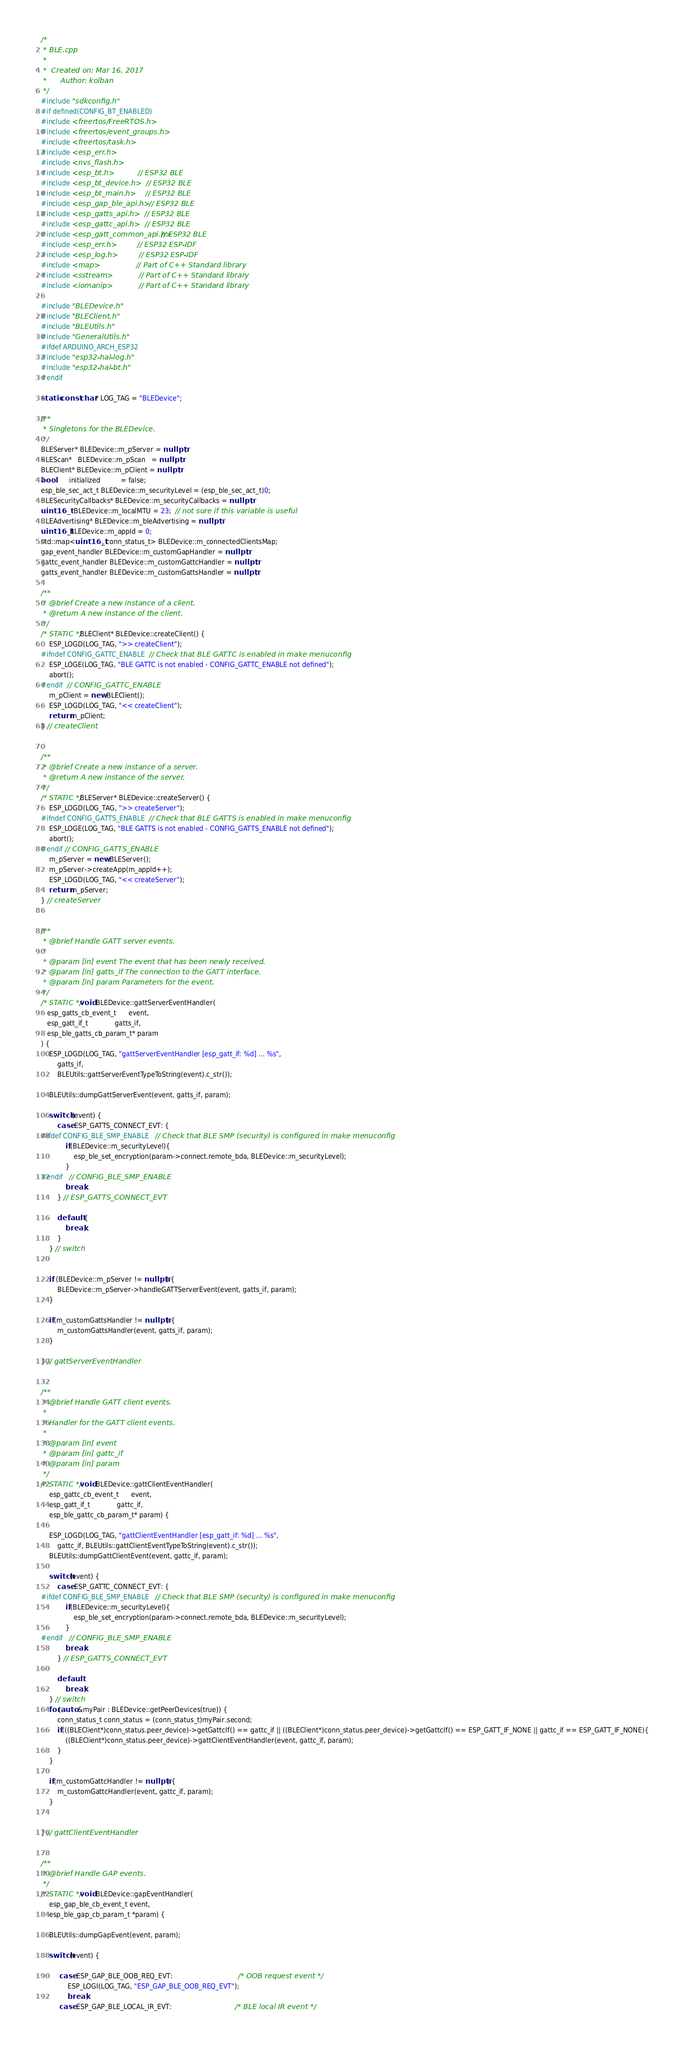Convert code to text. <code><loc_0><loc_0><loc_500><loc_500><_C++_>/*
 * BLE.cpp
 *
 *  Created on: Mar 16, 2017
 *      Author: kolban
 */
#include "sdkconfig.h"
#if defined(CONFIG_BT_ENABLED)
#include <freertos/FreeRTOS.h>
#include <freertos/event_groups.h>
#include <freertos/task.h>
#include <esp_err.h>
#include <nvs_flash.h>
#include <esp_bt.h>            // ESP32 BLE
#include <esp_bt_device.h>     // ESP32 BLE
#include <esp_bt_main.h>       // ESP32 BLE
#include <esp_gap_ble_api.h>   // ESP32 BLE
#include <esp_gatts_api.h>     // ESP32 BLE
#include <esp_gattc_api.h>     // ESP32 BLE
#include <esp_gatt_common_api.h>// ESP32 BLE
#include <esp_err.h>           // ESP32 ESP-IDF
#include <esp_log.h>           // ESP32 ESP-IDF
#include <map>                 // Part of C++ Standard library
#include <sstream>             // Part of C++ Standard library
#include <iomanip>             // Part of C++ Standard library

#include "BLEDevice.h"
#include "BLEClient.h"
#include "BLEUtils.h"
#include "GeneralUtils.h"
#ifdef ARDUINO_ARCH_ESP32
#include "esp32-hal-log.h"
#include "esp32-hal-bt.h"
#endif

static const char* LOG_TAG = "BLEDevice";

/**
 * Singletons for the BLEDevice.
 */
BLEServer* BLEDevice::m_pServer = nullptr;
BLEScan*   BLEDevice::m_pScan   = nullptr;
BLEClient* BLEDevice::m_pClient = nullptr;
bool       initialized          = false;  
esp_ble_sec_act_t BLEDevice::m_securityLevel = (esp_ble_sec_act_t)0;
BLESecurityCallbacks* BLEDevice::m_securityCallbacks = nullptr;
uint16_t   BLEDevice::m_localMTU = 23;  // not sure if this variable is useful
BLEAdvertising* BLEDevice::m_bleAdvertising = nullptr;
uint16_t BLEDevice::m_appId = 0;
std::map<uint16_t, conn_status_t> BLEDevice::m_connectedClientsMap;
gap_event_handler BLEDevice::m_customGapHandler = nullptr;
gattc_event_handler BLEDevice::m_customGattcHandler = nullptr;
gatts_event_handler BLEDevice::m_customGattsHandler = nullptr;

/**
 * @brief Create a new instance of a client.
 * @return A new instance of the client.
 */
/* STATIC */ BLEClient* BLEDevice::createClient() {
	ESP_LOGD(LOG_TAG, ">> createClient");
#ifndef CONFIG_GATTC_ENABLE  // Check that BLE GATTC is enabled in make menuconfig
	ESP_LOGE(LOG_TAG, "BLE GATTC is not enabled - CONFIG_GATTC_ENABLE not defined");
	abort();
#endif  // CONFIG_GATTC_ENABLE
	m_pClient = new BLEClient();
	ESP_LOGD(LOG_TAG, "<< createClient");
	return m_pClient;
} // createClient


/**
 * @brief Create a new instance of a server.
 * @return A new instance of the server.
 */
/* STATIC */ BLEServer* BLEDevice::createServer() {
	ESP_LOGD(LOG_TAG, ">> createServer");
#ifndef CONFIG_GATTS_ENABLE  // Check that BLE GATTS is enabled in make menuconfig
	ESP_LOGE(LOG_TAG, "BLE GATTS is not enabled - CONFIG_GATTS_ENABLE not defined");
	abort();
#endif // CONFIG_GATTS_ENABLE
	m_pServer = new BLEServer();
	m_pServer->createApp(m_appId++);
	ESP_LOGD(LOG_TAG, "<< createServer");
	return m_pServer;
} // createServer


/**
 * @brief Handle GATT server events.
 *
 * @param [in] event The event that has been newly received.
 * @param [in] gatts_if The connection to the GATT interface.
 * @param [in] param Parameters for the event.
 */
/* STATIC */ void BLEDevice::gattServerEventHandler(
   esp_gatts_cb_event_t      event,
   esp_gatt_if_t             gatts_if,
   esp_ble_gatts_cb_param_t* param
) {
	ESP_LOGD(LOG_TAG, "gattServerEventHandler [esp_gatt_if: %d] ... %s",
		gatts_if,
		BLEUtils::gattServerEventTypeToString(event).c_str());

	BLEUtils::dumpGattServerEvent(event, gatts_if, param);

	switch (event) {
		case ESP_GATTS_CONNECT_EVT: {
#ifdef CONFIG_BLE_SMP_ENABLE   // Check that BLE SMP (security) is configured in make menuconfig
			if(BLEDevice::m_securityLevel){
				esp_ble_set_encryption(param->connect.remote_bda, BLEDevice::m_securityLevel);
			}
#endif	// CONFIG_BLE_SMP_ENABLE
			break;
		} // ESP_GATTS_CONNECT_EVT

		default: {
			break;
		}
	} // switch


	if (BLEDevice::m_pServer != nullptr) {
		BLEDevice::m_pServer->handleGATTServerEvent(event, gatts_if, param);
	}

	if(m_customGattsHandler != nullptr) {
		m_customGattsHandler(event, gatts_if, param);
	}

} // gattServerEventHandler


/**
 * @brief Handle GATT client events.
 *
 * Handler for the GATT client events.
 *
 * @param [in] event
 * @param [in] gattc_if
 * @param [in] param
 */
/* STATIC */ void BLEDevice::gattClientEventHandler(
	esp_gattc_cb_event_t      event,
	esp_gatt_if_t             gattc_if,
	esp_ble_gattc_cb_param_t* param) {

	ESP_LOGD(LOG_TAG, "gattClientEventHandler [esp_gatt_if: %d] ... %s",
		gattc_if, BLEUtils::gattClientEventTypeToString(event).c_str());
	BLEUtils::dumpGattClientEvent(event, gattc_if, param);

	switch(event) {
		case ESP_GATTC_CONNECT_EVT: {
#ifdef CONFIG_BLE_SMP_ENABLE   // Check that BLE SMP (security) is configured in make menuconfig
			if(BLEDevice::m_securityLevel){
				esp_ble_set_encryption(param->connect.remote_bda, BLEDevice::m_securityLevel);
			}
#endif	// CONFIG_BLE_SMP_ENABLE
			break;
		} // ESP_GATTS_CONNECT_EVT

		default:
			break;
	} // switch
	for(auto &myPair : BLEDevice::getPeerDevices(true)) {
		conn_status_t conn_status = (conn_status_t)myPair.second;
		if(((BLEClient*)conn_status.peer_device)->getGattcIf() == gattc_if || ((BLEClient*)conn_status.peer_device)->getGattcIf() == ESP_GATT_IF_NONE || gattc_if == ESP_GATT_IF_NONE){
			((BLEClient*)conn_status.peer_device)->gattClientEventHandler(event, gattc_if, param);
		}
	}

	if(m_customGattcHandler != nullptr) {
		m_customGattcHandler(event, gattc_if, param);
	}


} // gattClientEventHandler


/**
 * @brief Handle GAP events.
 */
/* STATIC */ void BLEDevice::gapEventHandler(
	esp_gap_ble_cb_event_t event,
	esp_ble_gap_cb_param_t *param) {

	BLEUtils::dumpGapEvent(event, param);

	switch(event) {

		 case ESP_GAP_BLE_OOB_REQ_EVT:                                /* OOB request event */
			 ESP_LOGI(LOG_TAG, "ESP_GAP_BLE_OOB_REQ_EVT");
			 break;
		 case ESP_GAP_BLE_LOCAL_IR_EVT:                               /* BLE local IR event */</code> 